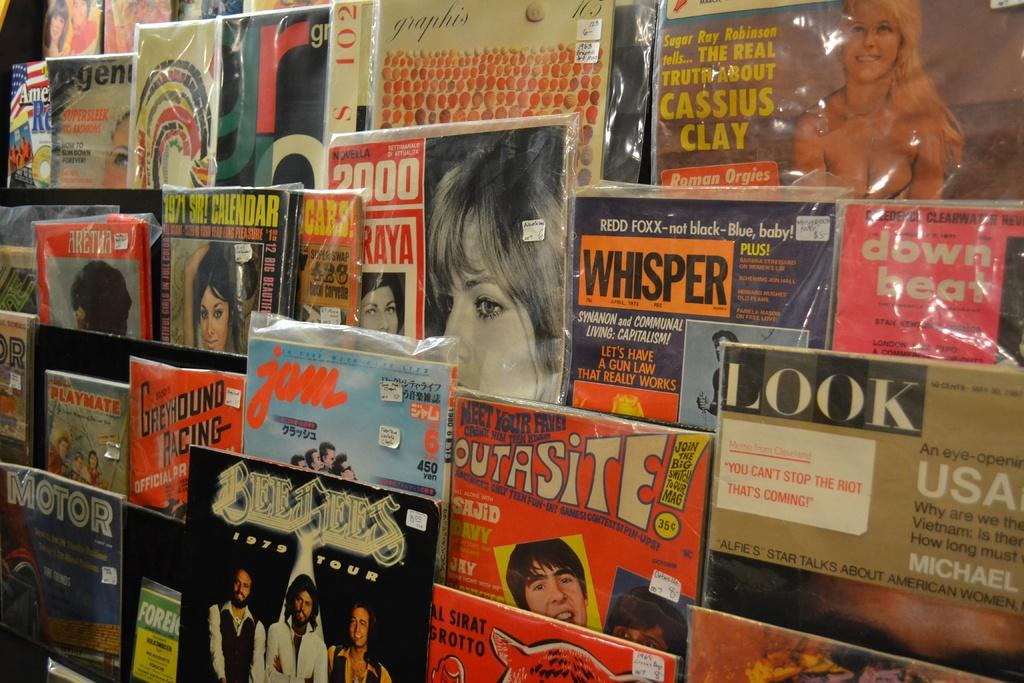<image>
Share a concise interpretation of the image provided. Magazines are on display and one says BEE GEES 1979 TOUR on the front. 